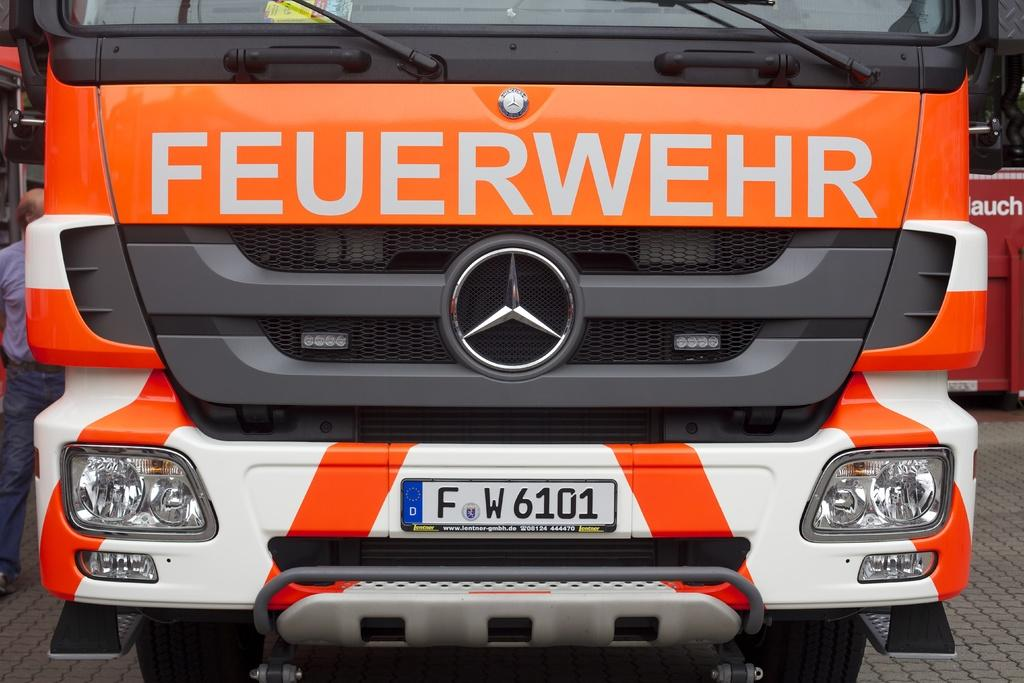What is the main subject in the middle of the image? There is a bus in the middle of the image. What can be seen on the left side of the image? There is a man on the left side of the image. What is the man wearing? The man is wearing a shirt and trousers. What is the man doing in the image? The man is walking. What is the surface on which the man is walking? There is a floor visible in the image. What type of berry can be seen growing on the bus in the image? There are no berries present on the bus in the image. Can you tell me how many grapes are visible on the man's shirt? There are no grapes visible on the man's shirt in the image. 